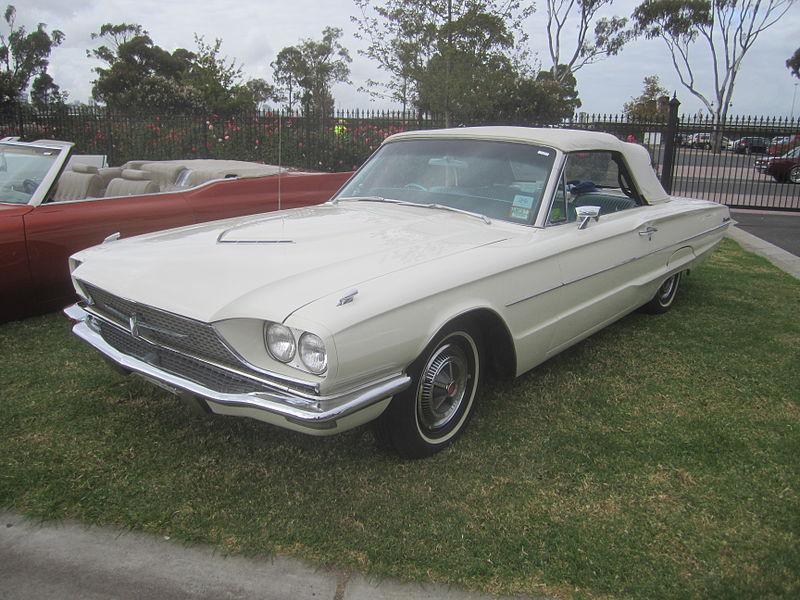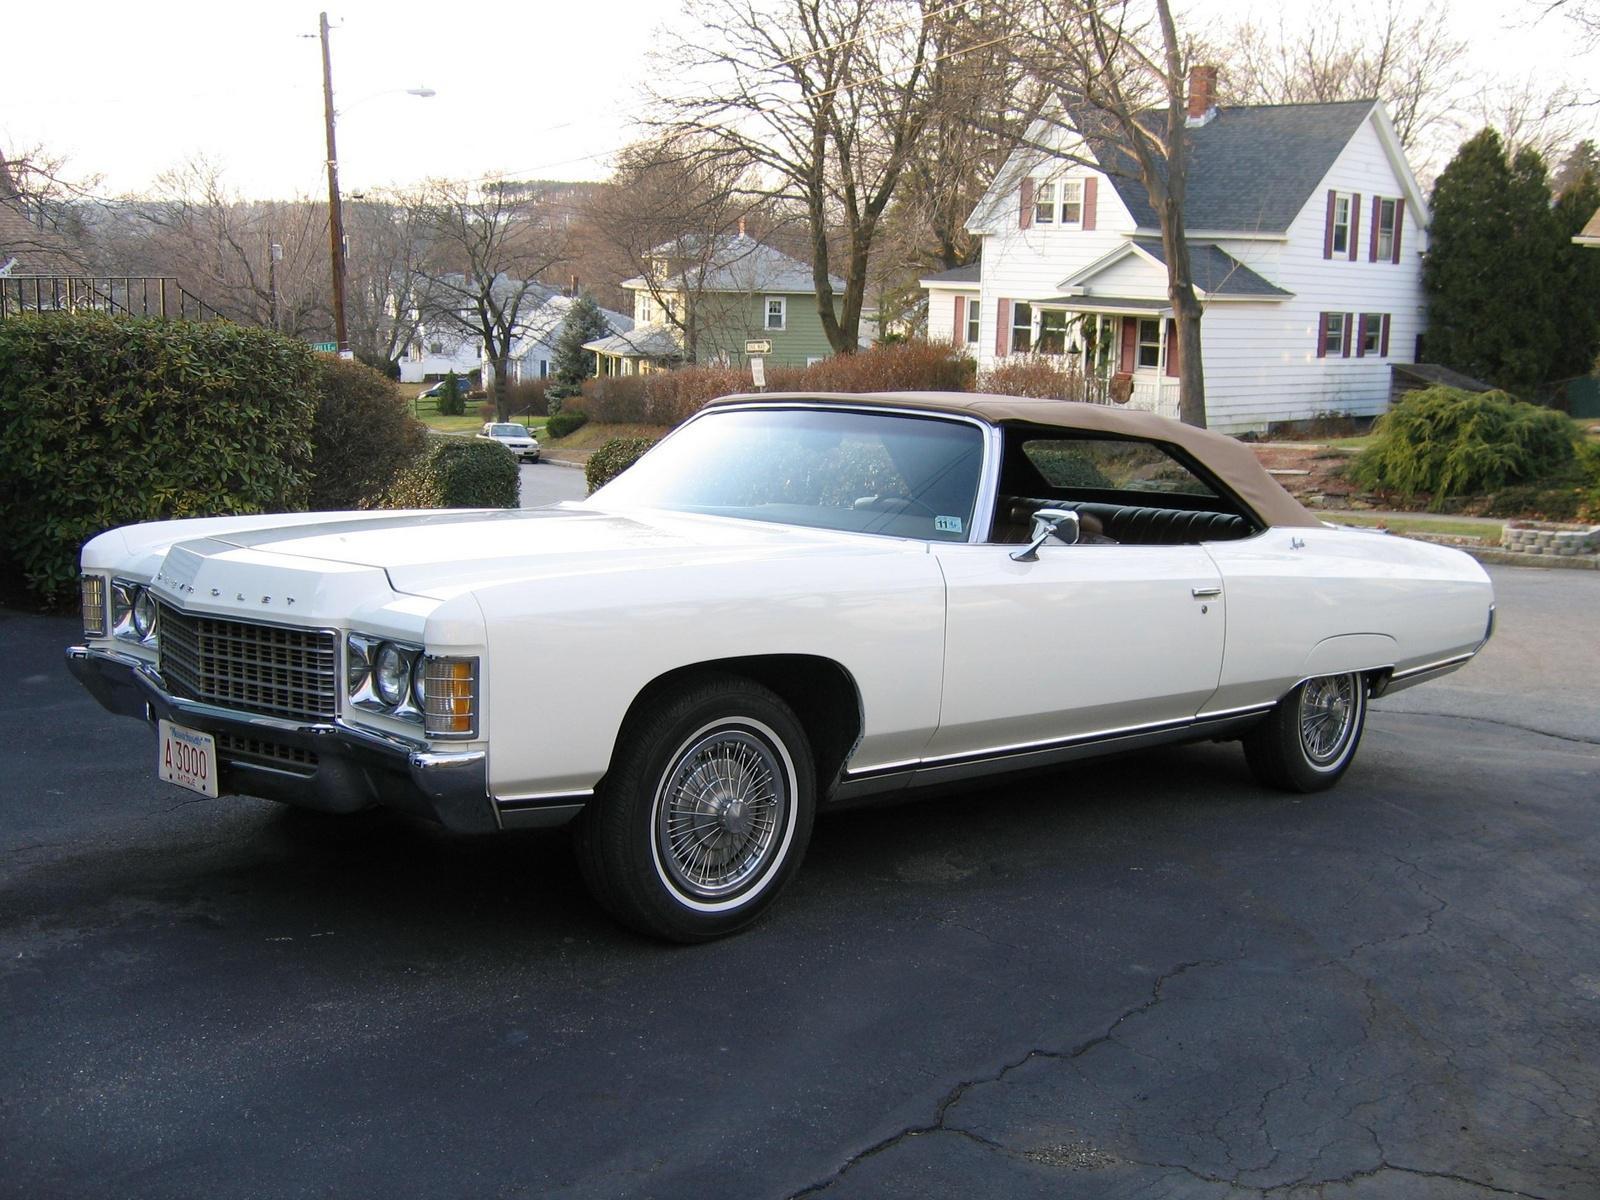The first image is the image on the left, the second image is the image on the right. Evaluate the accuracy of this statement regarding the images: "Two predominantly white convertibles have the tops down, one facing towards the front and one to the back.". Is it true? Answer yes or no. No. 